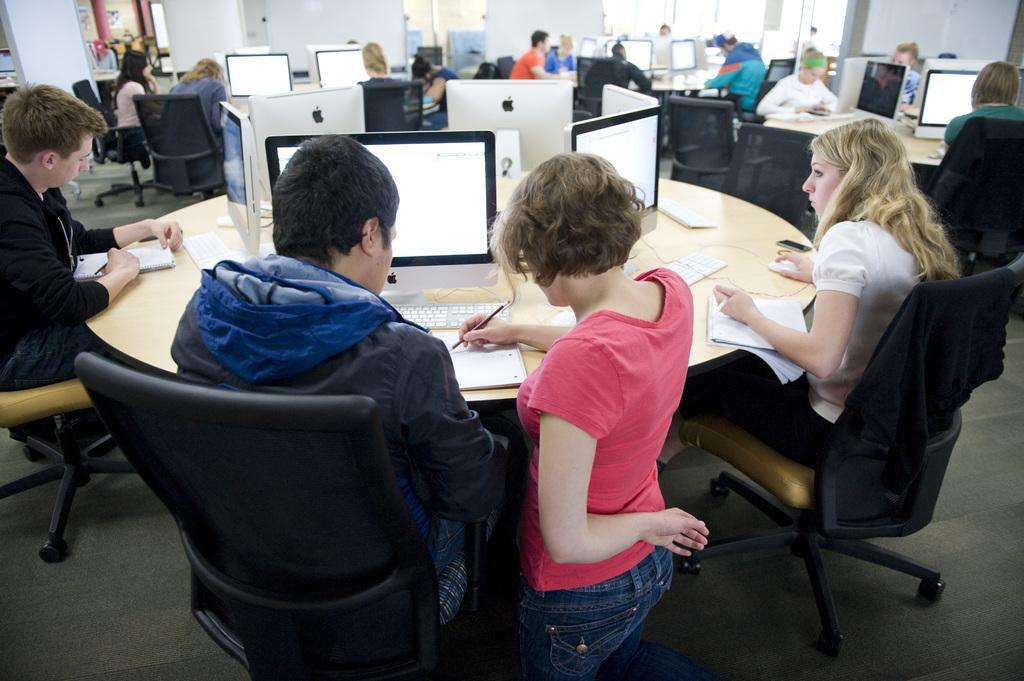How would you summarize this image in a sentence or two? In this image we can see there are so many tables, around the tables there are a few people sitting, one of them is sitting on her knees. On the table there are monitors, keyboard, mouse, books and few are holding pens in their hands. In the background there are few boards and a wall. 